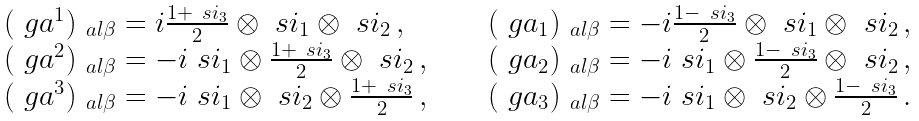Convert formula to latex. <formula><loc_0><loc_0><loc_500><loc_500>\begin{array} { l c l } ( \ g a ^ { 1 } ) _ { \ a l \beta } = i \frac { 1 + \ s i _ { 3 } } { 2 } \otimes \ s i _ { 1 } \otimes \ s i _ { 2 } \, , & \quad & ( \ g a _ { 1 } ) _ { \ a l \beta } = - i \frac { 1 - \ s i _ { 3 } } { 2 } \otimes \ s i _ { 1 } \otimes \ s i _ { 2 } \, , \\ ( \ g a ^ { 2 } ) _ { \ a l \beta } = - i \ s i _ { 1 } \otimes \frac { 1 + \ s i _ { 3 } } { 2 } \otimes \ s i _ { 2 } \, , & \quad & ( \ g a _ { 2 } ) _ { \ a l \beta } = - i \ s i _ { 1 } \otimes \frac { 1 - \ s i _ { 3 } } { 2 } \otimes \ s i _ { 2 } \, , \\ ( \ g a ^ { 3 } ) _ { \ a l \beta } = - i \ s i _ { 1 } \otimes \ s i _ { 2 } \otimes \frac { 1 + \ s i _ { 3 } } { 2 } \, , & \quad & ( \ g a _ { 3 } ) _ { \ a l \beta } = - i \ s i _ { 1 } \otimes \ s i _ { 2 } \otimes \frac { 1 - \ s i _ { 3 } } { 2 } \, . \end{array}</formula> 